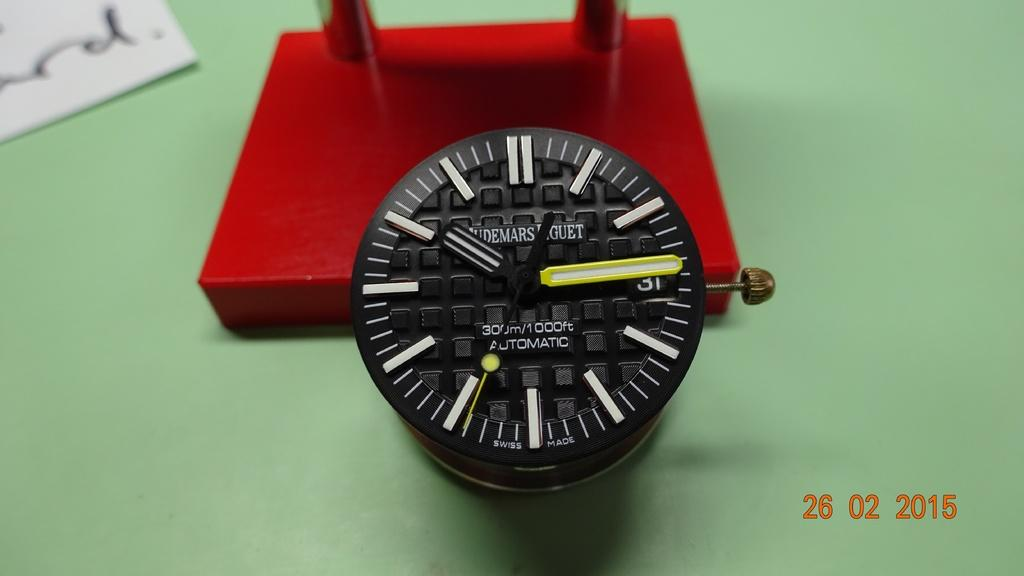<image>
Share a concise interpretation of the image provided. A watch that says "automatic" on the face also says 1000 feet. 